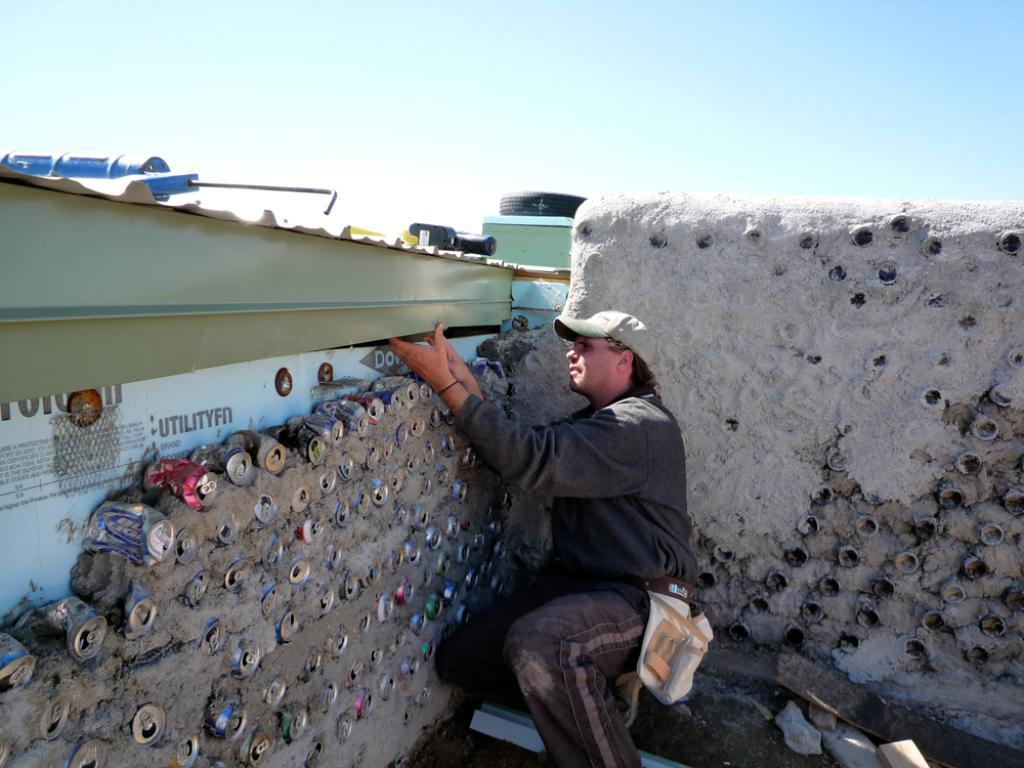<image>
Give a short and clear explanation of the subsequent image. A construction worker is building a wall using Utilityfit as a base layer. 